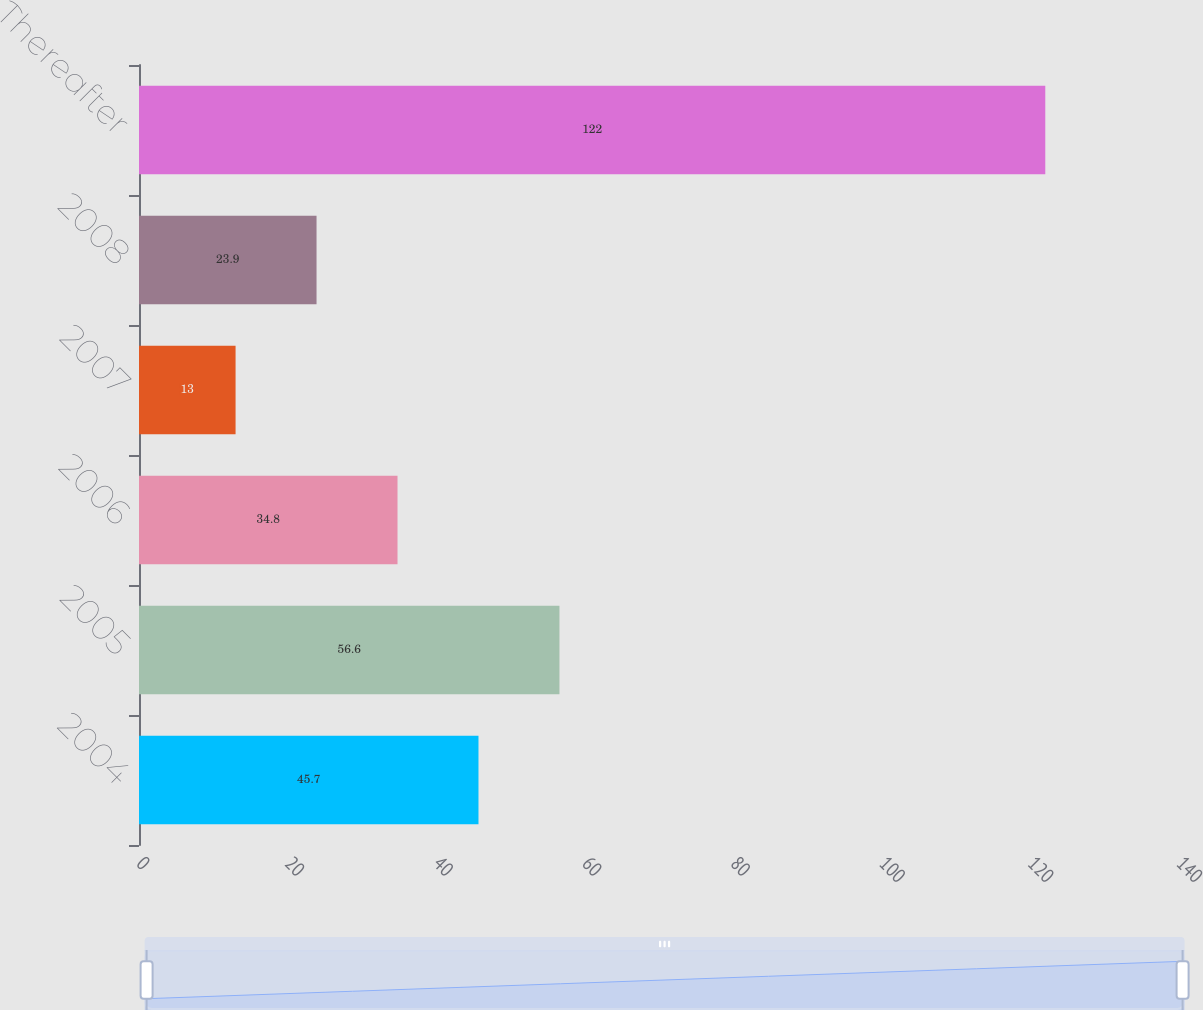<chart> <loc_0><loc_0><loc_500><loc_500><bar_chart><fcel>2004<fcel>2005<fcel>2006<fcel>2007<fcel>2008<fcel>Thereafter<nl><fcel>45.7<fcel>56.6<fcel>34.8<fcel>13<fcel>23.9<fcel>122<nl></chart> 